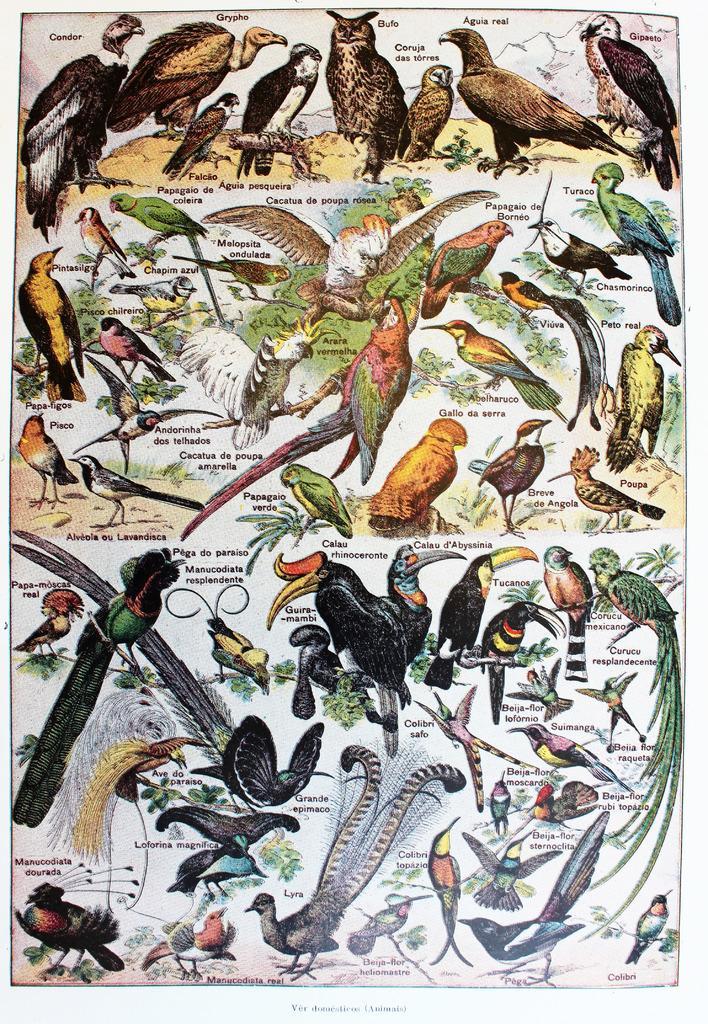Could you give a brief overview of what you see in this image? This might be a poster, in this image there are different types of birds and some text. 